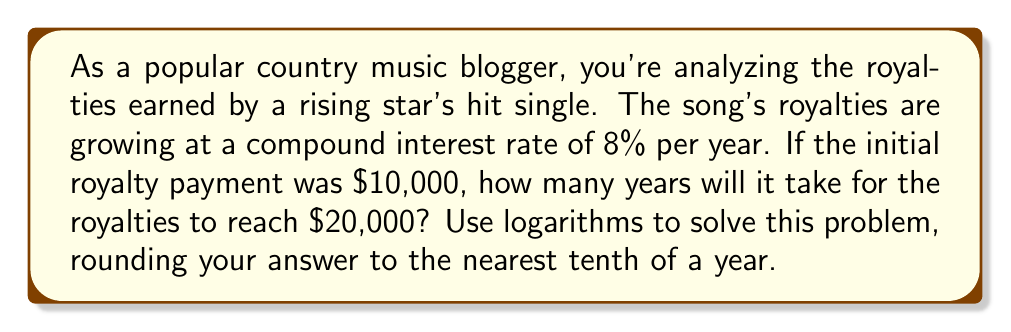What is the answer to this math problem? To solve this problem, we'll use the compound interest formula and logarithms. Let's break it down step-by-step:

1) The compound interest formula is:
   $$A = P(1 + r)^t$$
   Where:
   $A$ = Final amount
   $P$ = Principal (initial amount)
   $r$ = Annual interest rate (as a decimal)
   $t$ = Time in years

2) We know:
   $A = \$20,000$ (target amount)
   $P = \$10,000$ (initial royalty payment)
   $r = 0.08$ (8% as a decimal)
   We need to solve for $t$

3) Let's plug these values into the formula:
   $$20000 = 10000(1 + 0.08)^t$$

4) Divide both sides by 10000:
   $$2 = (1.08)^t$$

5) To solve for $t$, we need to use logarithms. We can use any base, but let's use natural log (ln) for simplicity:
   $$\ln(2) = \ln((1.08)^t)$$

6) Using the logarithm property $\ln(a^b) = b\ln(a)$, we get:
   $$\ln(2) = t \ln(1.08)$$

7) Now we can solve for $t$:
   $$t = \frac{\ln(2)}{\ln(1.08)}$$

8) Using a calculator:
   $$t \approx 9.006$$

9) Rounding to the nearest tenth:
   $$t \approx 9.0\text{ years}$$
Answer: It will take approximately 9.0 years for the royalties to reach $20,000. 